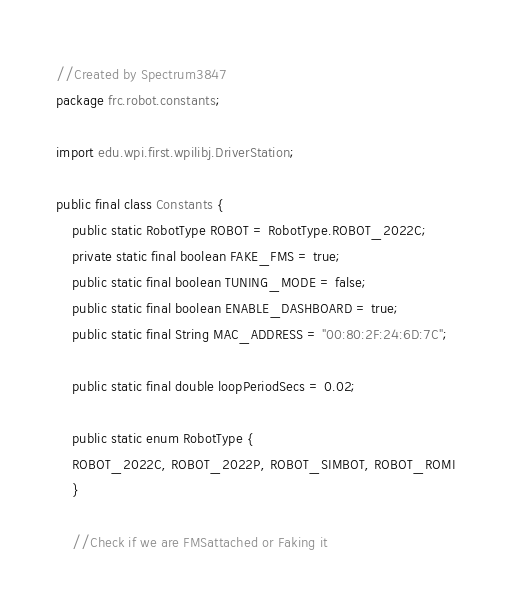<code> <loc_0><loc_0><loc_500><loc_500><_Java_>//Created by Spectrum3847
package frc.robot.constants;

import edu.wpi.first.wpilibj.DriverStation;

public final class Constants {
    public static RobotType ROBOT = RobotType.ROBOT_2022C;
    private static final boolean FAKE_FMS = true;
    public static final boolean TUNING_MODE = false;
    public static final boolean ENABLE_DASHBOARD = true;
    public static final String MAC_ADDRESS = "00:80:2F:24:6D:7C";
    
    public static final double loopPeriodSecs = 0.02;

    public static enum RobotType {
    ROBOT_2022C, ROBOT_2022P, ROBOT_SIMBOT, ROBOT_ROMI
    }

    //Check if we are FMSattached or Faking it</code> 